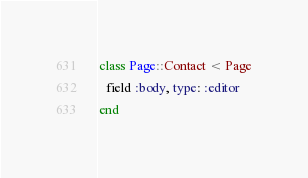Convert code to text. <code><loc_0><loc_0><loc_500><loc_500><_Ruby_>class Page::Contact < Page
  field :body, type: :editor
end
</code> 